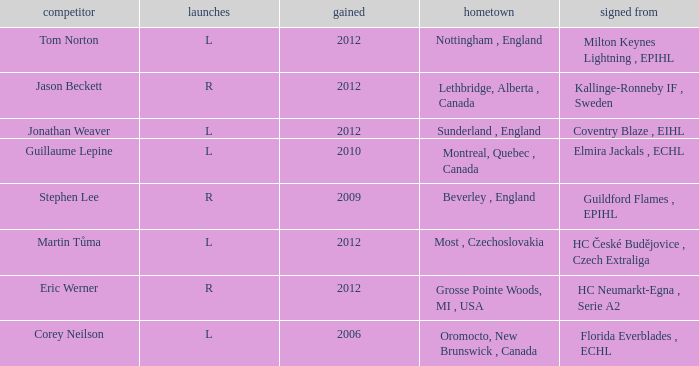Who acquired tom norton? 2012.0. 